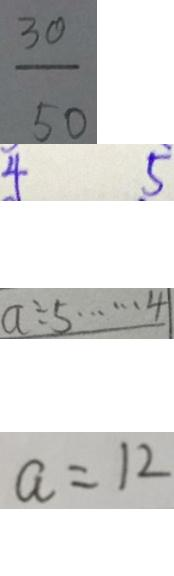Convert formula to latex. <formula><loc_0><loc_0><loc_500><loc_500>\frac { 3 0 } { 5 0 } 
 4 5 
 a \div 5 \cdots 4 
 a = 1 2</formula> 